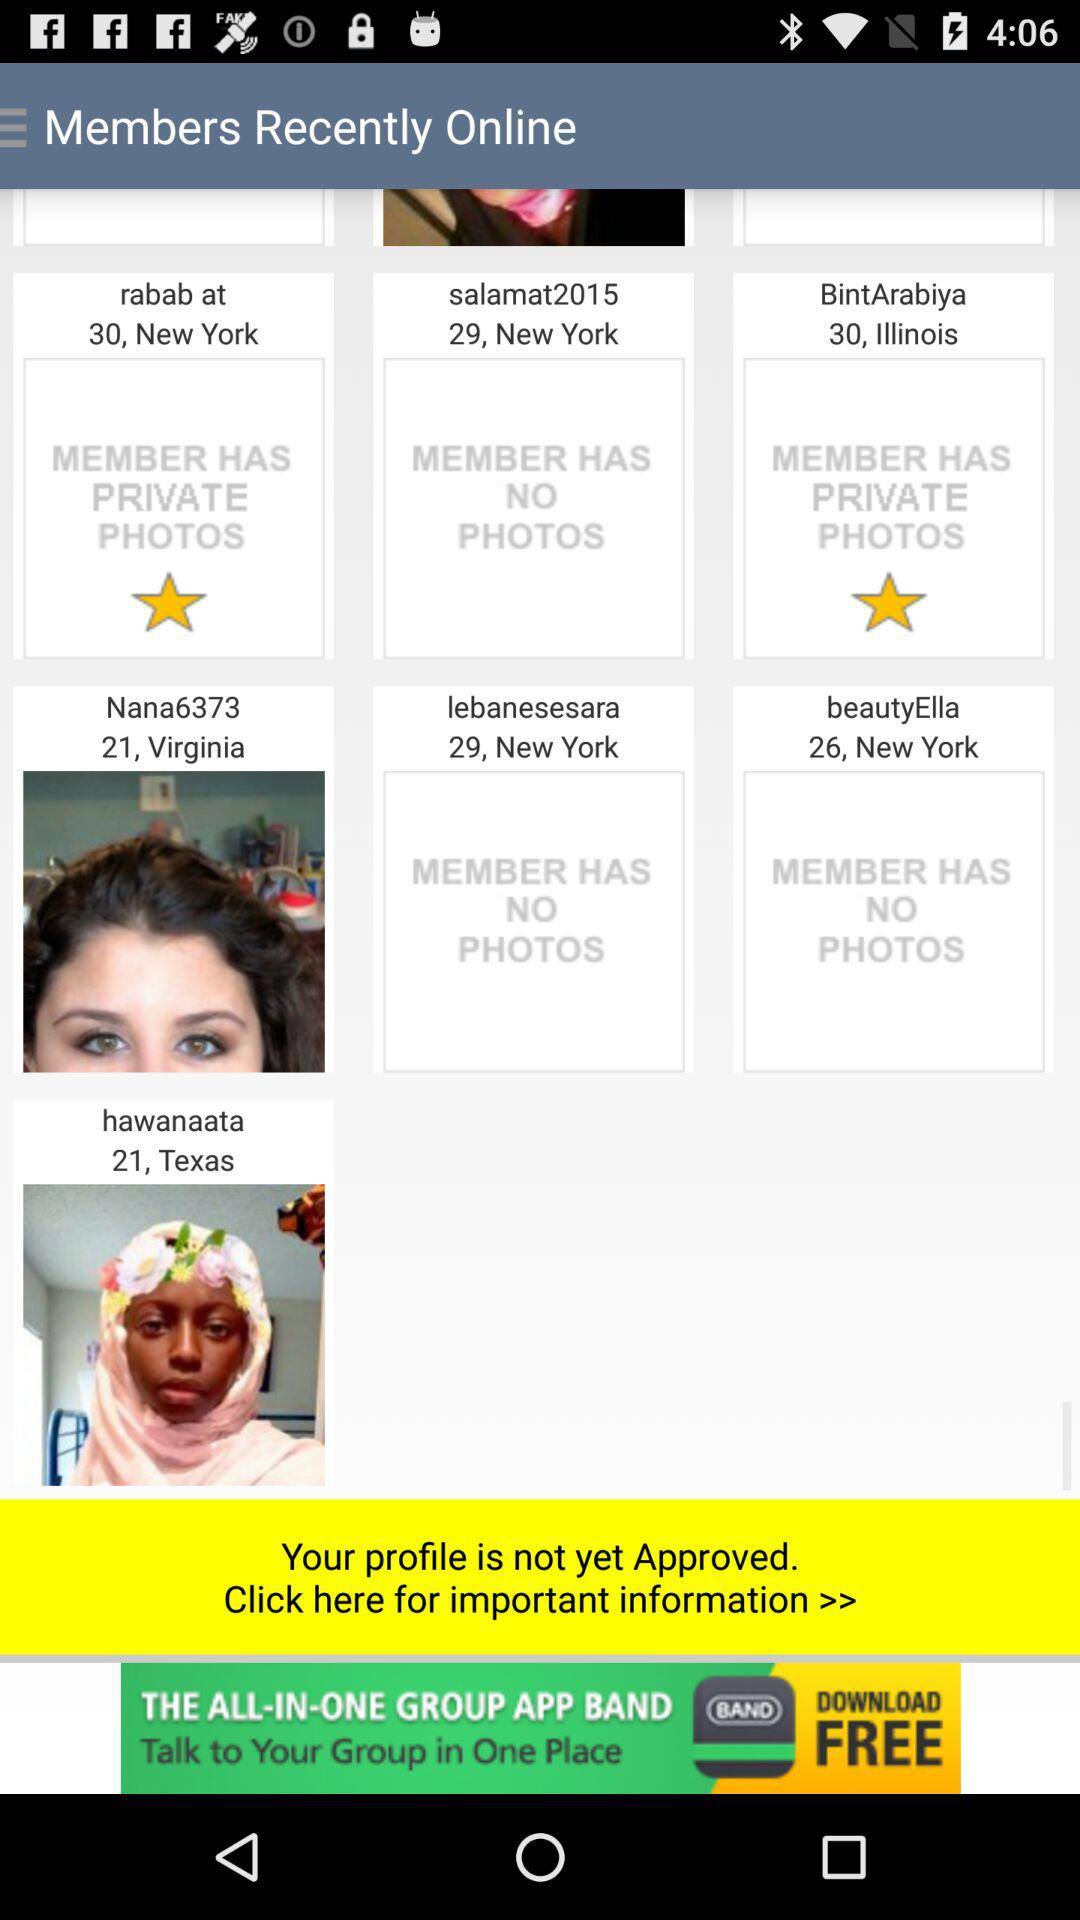When was "hawanaata" last online?
When the provided information is insufficient, respond with <no answer>. <no answer> 